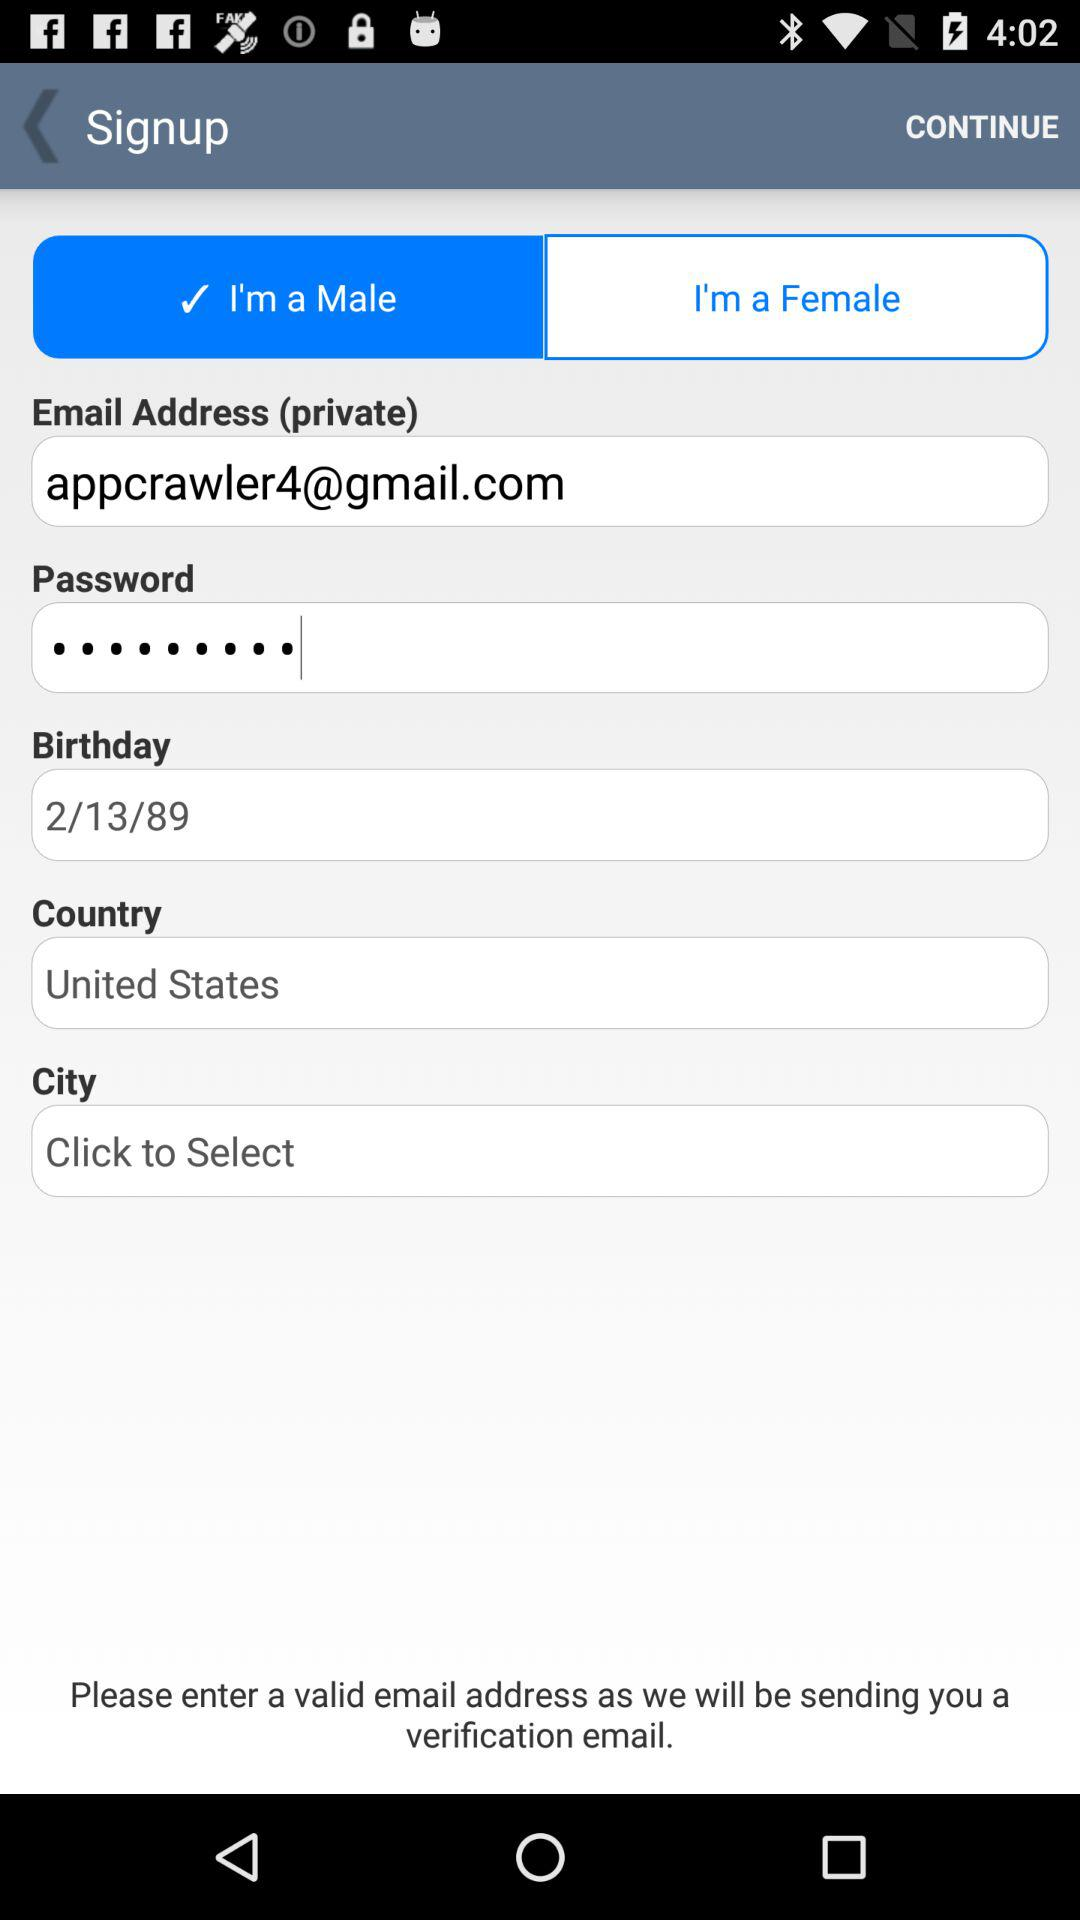What is the birth date of the user? The birth date of the user is February 13, 1989. 